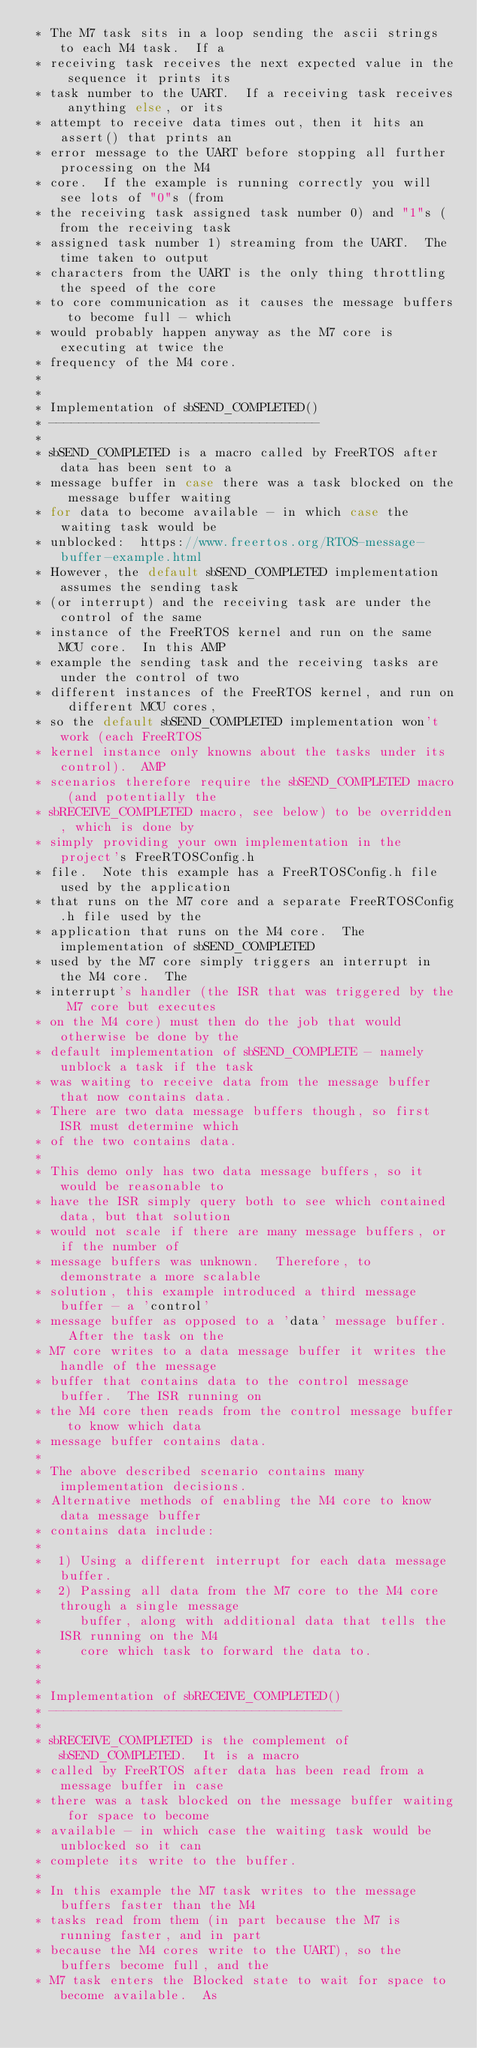<code> <loc_0><loc_0><loc_500><loc_500><_C_> * The M7 task sits in a loop sending the ascii strings to each M4 task.  If a
 * receiving task receives the next expected value in the sequence it prints its
 * task number to the UART.  If a receiving task receives anything else, or its
 * attempt to receive data times out, then it hits an assert() that prints an
 * error message to the UART before stopping all further processing on the M4
 * core.  If the example is running correctly you will see lots of "0"s (from
 * the receiving task assigned task number 0) and "1"s (from the receiving task
 * assigned task number 1) streaming from the UART.  The time taken to output
 * characters from the UART is the only thing throttling the speed of the core
 * to core communication as it causes the message buffers to become full - which
 * would probably happen anyway as the M7 core is executing at twice the
 * frequency of the M4 core.
 *
 *
 * Implementation of sbSEND_COMPLETED()
 * ------------------------------------
 *
 * sbSEND_COMPLETED is a macro called by FreeRTOS after data has been sent to a
 * message buffer in case there was a task blocked on the message buffer waiting
 * for data to become available - in which case the waiting task would be
 * unblocked:  https://www.freertos.org/RTOS-message-buffer-example.html
 * However, the default sbSEND_COMPLETED implementation assumes the sending task
 * (or interrupt) and the receiving task are under the control of the same
 * instance of the FreeRTOS kernel and run on the same MCU core.  In this AMP
 * example the sending task and the receiving tasks are under the control of two
 * different instances of the FreeRTOS kernel, and run on different MCU cores,
 * so the default sbSEND_COMPLETED implementation won't work (each FreeRTOS
 * kernel instance only knowns about the tasks under its control).  AMP
 * scenarios therefore require the sbSEND_COMPLETED macro (and potentially the
 * sbRECEIVE_COMPLETED macro, see below) to be overridden, which is done by
 * simply providing your own implementation in the project's FreeRTOSConfig.h
 * file.  Note this example has a FreeRTOSConfig.h file used by the application
 * that runs on the M7 core and a separate FreeRTOSConfig.h file used by the
 * application that runs on the M4 core.  The implementation of sbSEND_COMPLETED
 * used by the M7 core simply triggers an interrupt in the M4 core.  The
 * interrupt's handler (the ISR that was triggered by the M7 core but executes
 * on the M4 core) must then do the job that would otherwise be done by the
 * default implementation of sbSEND_COMPLETE - namely unblock a task if the task
 * was waiting to receive data from the message buffer that now contains data.
 * There are two data message buffers though, so first ISR must determine which
 * of the two contains data.
 *
 * This demo only has two data message buffers, so it would be reasonable to
 * have the ISR simply query both to see which contained data, but that solution
 * would not scale if there are many message buffers, or if the number of
 * message buffers was unknown.  Therefore, to demonstrate a more scalable
 * solution, this example introduced a third message buffer - a 'control'
 * message buffer as opposed to a 'data' message buffer.  After the task on the
 * M7 core writes to a data message buffer it writes the handle of the message
 * buffer that contains data to the control message buffer.  The ISR running on
 * the M4 core then reads from the control message buffer to know which data
 * message buffer contains data.
 *
 * The above described scenario contains many implementation decisions.
 * Alternative methods of enabling the M4 core to know data message buffer
 * contains data include:
 *
 *  1) Using a different interrupt for each data message buffer.
 *  2) Passing all data from the M7 core to the M4 core through a single message
 *     buffer, along with additional data that tells the ISR running on the M4
 *     core which task to forward the data to.
 *
 *
 * Implementation of sbRECEIVE_COMPLETED()
 * ---------------------------------------
 *
 * sbRECEIVE_COMPLETED is the complement of sbSEND_COMPLETED.  It is a macro
 * called by FreeRTOS after data has been read from a message buffer in case
 * there was a task blocked on the message buffer waiting for space to become
 * available - in which case the waiting task would be unblocked so it can
 * complete its write to the buffer.
 *
 * In this example the M7 task writes to the message buffers faster than the M4
 * tasks read from them (in part because the M7 is running faster, and in part
 * because the M4 cores write to the UART), so the buffers become full, and the
 * M7 task enters the Blocked state to wait for space to become available.  As</code> 